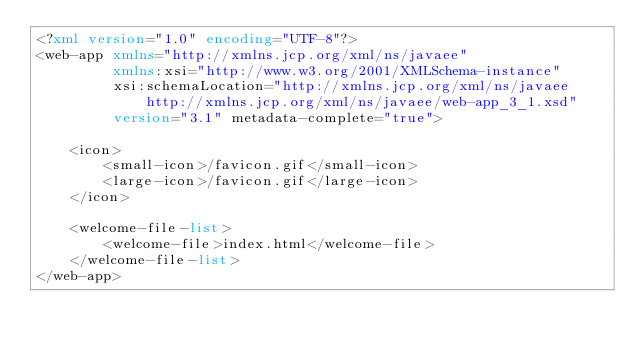Convert code to text. <code><loc_0><loc_0><loc_500><loc_500><_XML_><?xml version="1.0" encoding="UTF-8"?>
<web-app xmlns="http://xmlns.jcp.org/xml/ns/javaee"
         xmlns:xsi="http://www.w3.org/2001/XMLSchema-instance"
         xsi:schemaLocation="http://xmlns.jcp.org/xml/ns/javaee http://xmlns.jcp.org/xml/ns/javaee/web-app_3_1.xsd"
         version="3.1" metadata-complete="true">

    <icon>
        <small-icon>/favicon.gif</small-icon>
        <large-icon>/favicon.gif</large-icon>
    </icon>

    <welcome-file-list>
        <welcome-file>index.html</welcome-file>
    </welcome-file-list>
</web-app></code> 